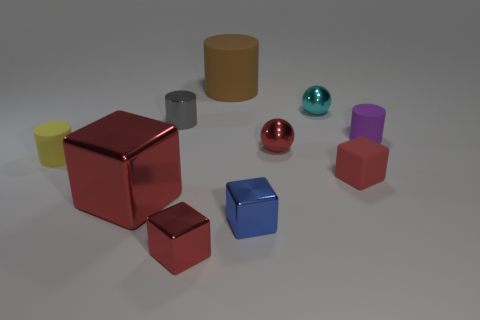How many red blocks must be subtracted to get 1 red blocks? 2 Subtract all cyan cylinders. How many red cubes are left? 3 Subtract all balls. How many objects are left? 8 Subtract 0 red cylinders. How many objects are left? 10 Subtract all gray blocks. Subtract all red rubber things. How many objects are left? 9 Add 9 yellow things. How many yellow things are left? 10 Add 8 tiny gray objects. How many tiny gray objects exist? 9 